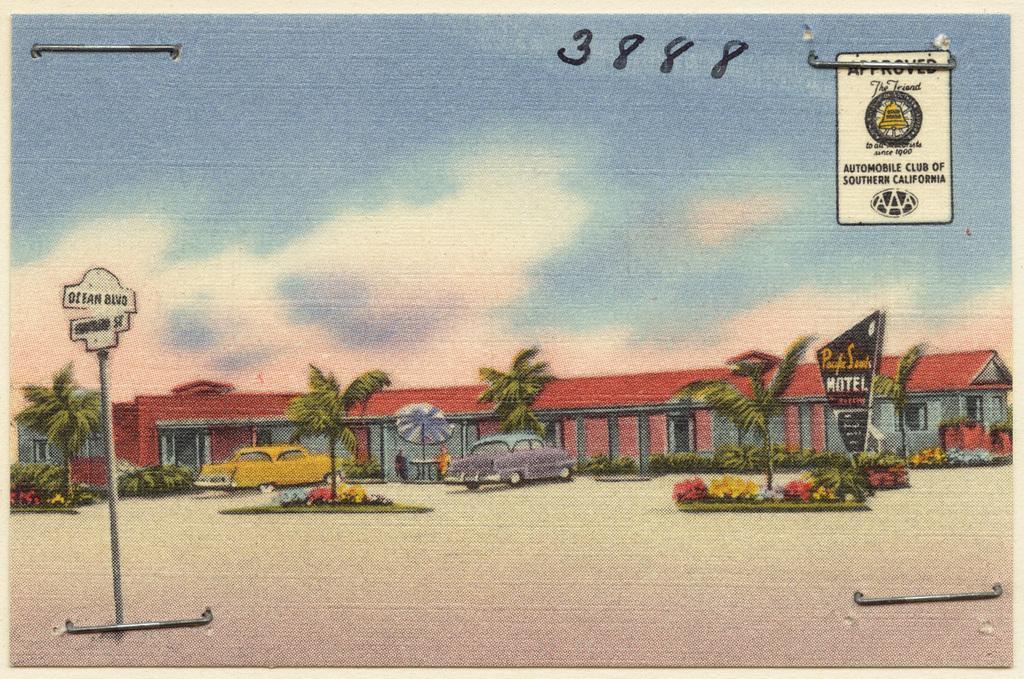Describe this image in one or two sentences. As we can see in the image there is painting of buildings, cars, flowers, trees, sign board and sky. 